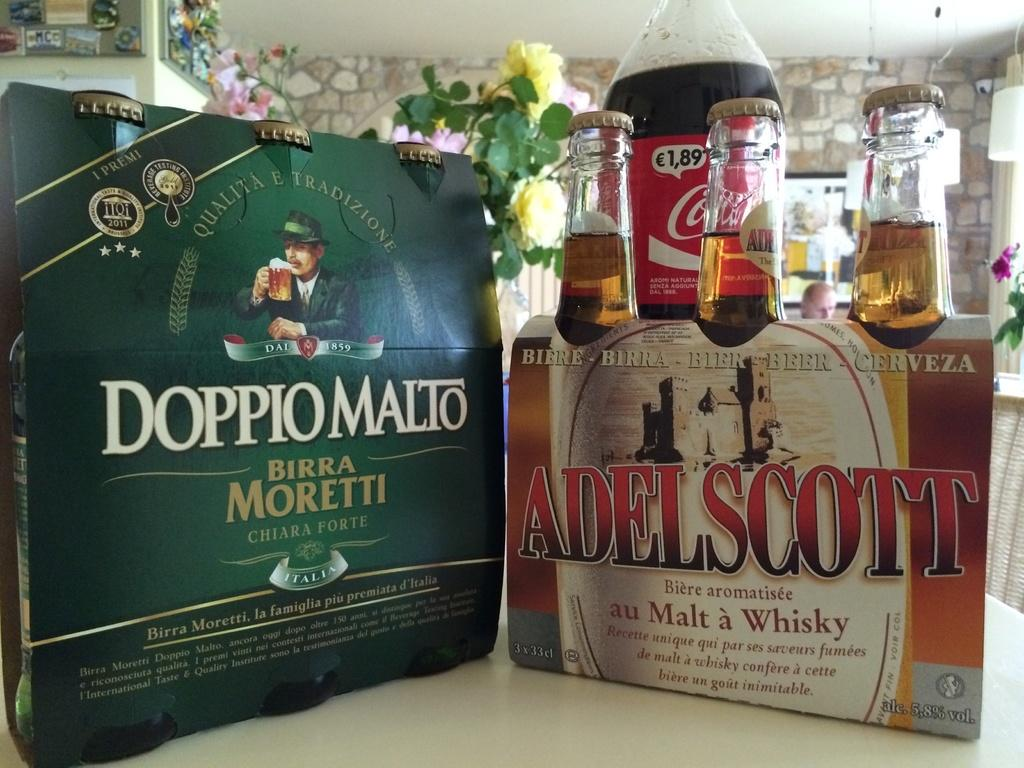<image>
Write a terse but informative summary of the picture. Bottle of Adelscott sit in front of a bottle of Coke. 